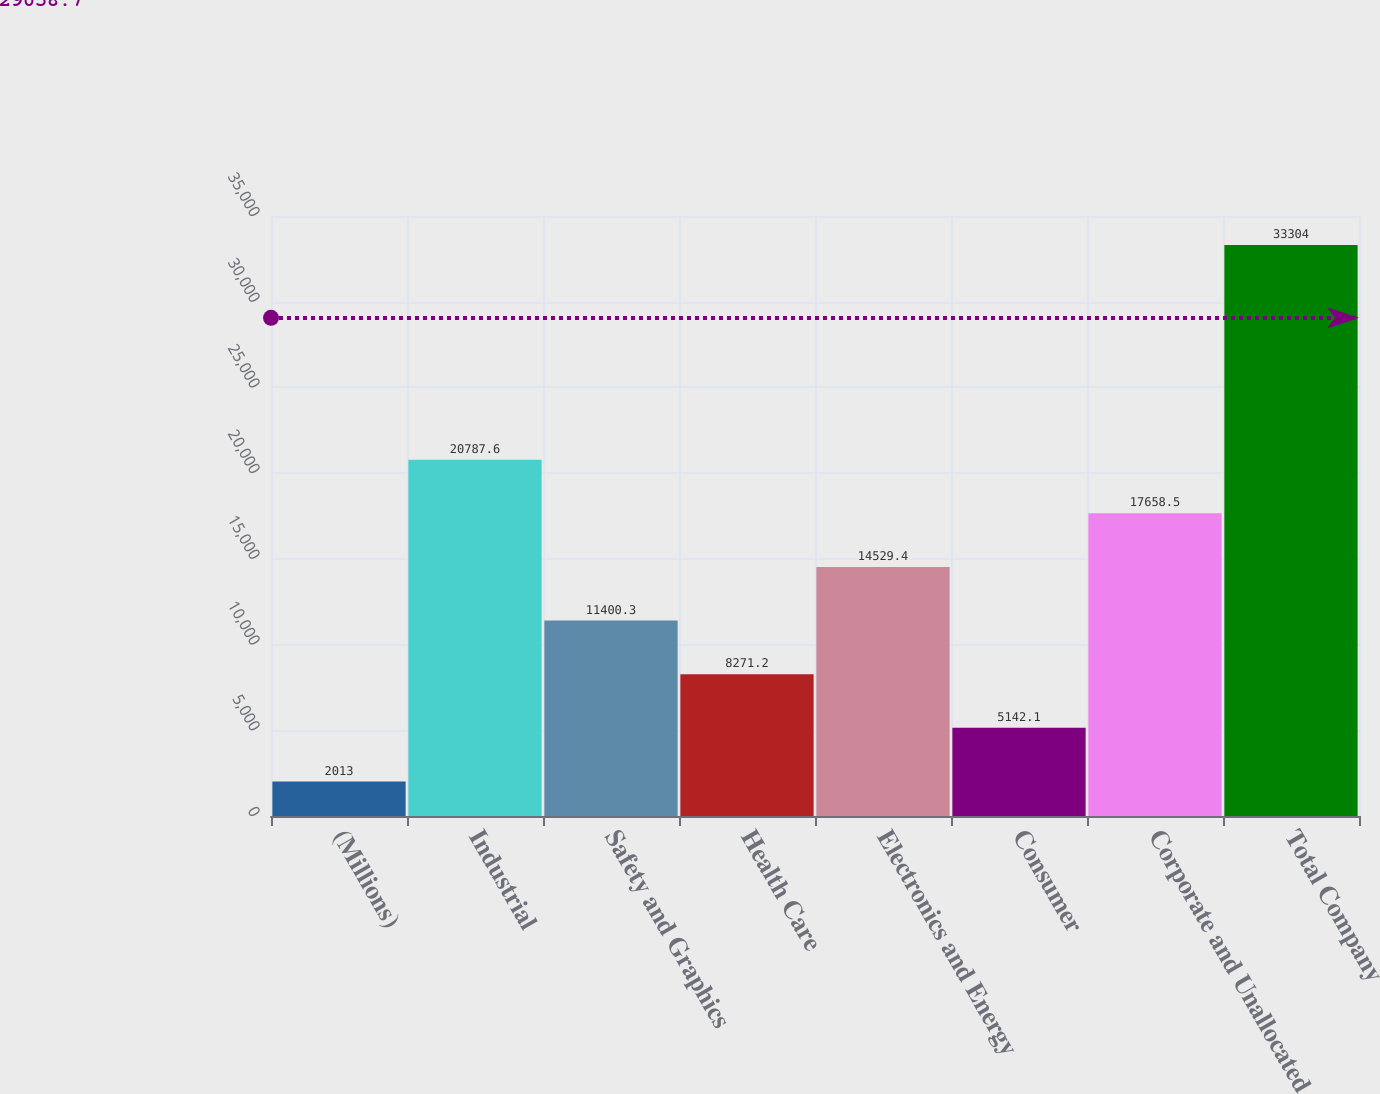Convert chart. <chart><loc_0><loc_0><loc_500><loc_500><bar_chart><fcel>(Millions)<fcel>Industrial<fcel>Safety and Graphics<fcel>Health Care<fcel>Electronics and Energy<fcel>Consumer<fcel>Corporate and Unallocated<fcel>Total Company<nl><fcel>2013<fcel>20787.6<fcel>11400.3<fcel>8271.2<fcel>14529.4<fcel>5142.1<fcel>17658.5<fcel>33304<nl></chart> 